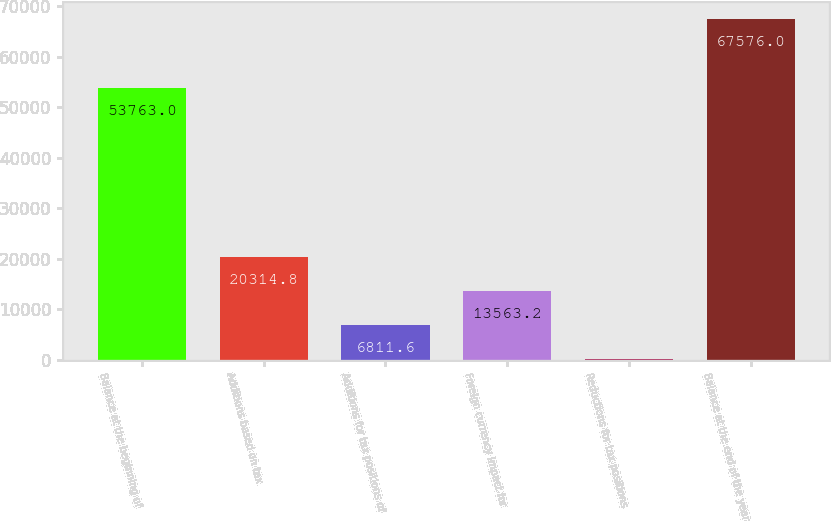Convert chart to OTSL. <chart><loc_0><loc_0><loc_500><loc_500><bar_chart><fcel>Balance at the beginning of<fcel>Additions based on tax<fcel>Additions for tax positions of<fcel>Foreign currency impact for<fcel>Reductions for tax positions<fcel>Balance at the end of the year<nl><fcel>53763<fcel>20314.8<fcel>6811.6<fcel>13563.2<fcel>60<fcel>67576<nl></chart> 